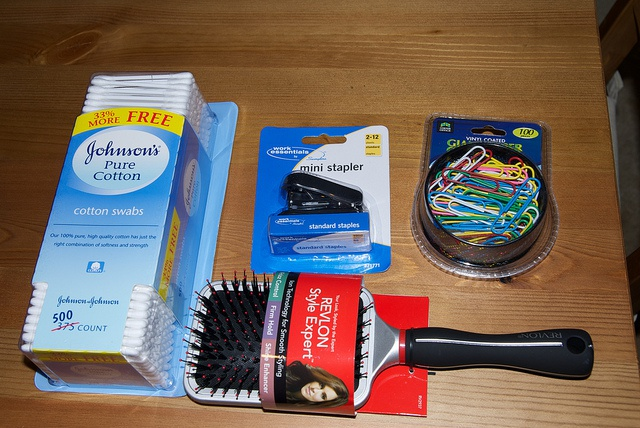Describe the objects in this image and their specific colors. I can see a dining table in maroon, brown, and black tones in this image. 